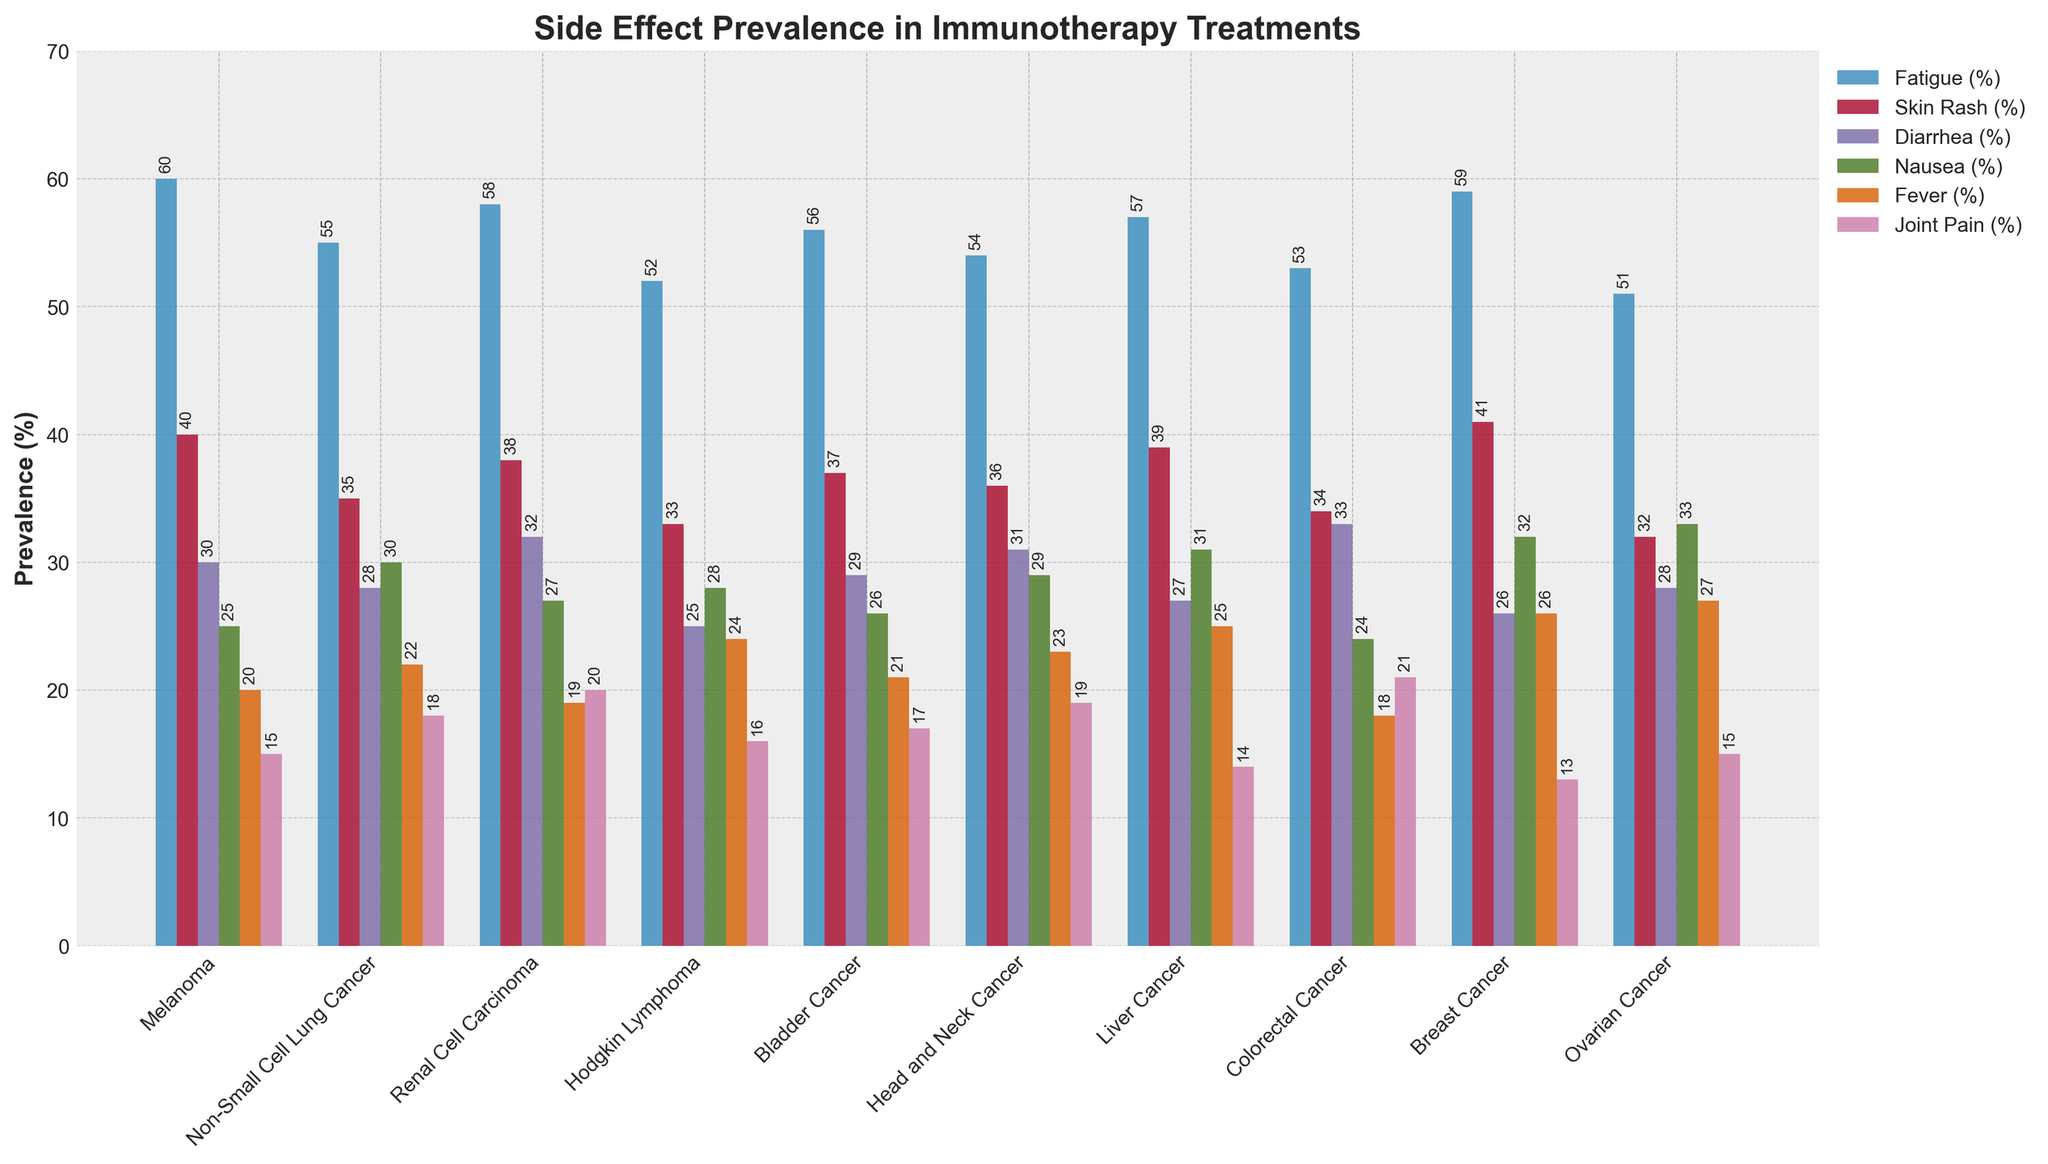Which cancer type has the highest prevalence of fatigue? The figure shows the prevalence of different side effects for various cancer types. By visually inspecting the bar representing fatigue across all cancer types, the highest one corresponds to Melanoma.
Answer: Melanoma What is the difference in the prevalence of fatigue between Melanoma and Non-Small Cell Lung Cancer? From the figure, the fatigue prevalence for Melanoma and Non-Small Cell Lung Cancer are 60% and 55% respectively. The difference is calculated as 60% - 55%.
Answer: 5% Which side effect has the largest difference in prevalence between Breast Cancer and Ovarian Cancer? By comparing the prevalence for each side effect between Breast Cancer and Ovarian Cancer, noting the differences: Fatigue (59% - 51%), Skin Rash (41% - 32%), Diarrhea (26% - 28%), Nausea (32% - 33%), Fever (26% - 27%), Joint Pain (13% - 15%). The largest difference is in Skin Rash (41% - 32%) = 9%.
Answer: Skin Rash Which two cancer types have an equal prevalence of nausea? By comparing the nausea prevalence across cancer types, both Liver Cancer and Breast Cancer show the same prevalence of 32%.
Answer: Liver Cancer and Breast Cancer What is the average prevalence of skin rash for all cancer types? Sum up the skin rash percentages for all cancer types (40% + 35% + 38% + 33% + 37% + 36% + 39% + 34% + 41% + 32%) = 365%. Then divide by the number of cancer types, which is 10. 365% / 10 = 36.5%.
Answer: 36.5% Which cancer type has the lowest prevalence of joint pain? The lowest prevalence of joint pain across all cancer types visually is Breast Cancer at 13%.
Answer: Breast Cancer What is the total prevalence of all side effects for Colorectal Cancer? Sum the prevalence percentages for fatigue, skin rash, diarrhea, nausea, fever, and joint pain for Colorectal Cancer (53% + 34% + 33% + 24% + 18% + 21%) = 183%.
Answer: 183% Which cancer type has a higher prevalence of diarrhea, Renal Cell Carcinoma or Head and Neck Cancer? By comparing the bars representing diarrhea for Renal Cell Carcinoma (32%) and Head and Neck Cancer (31%), Renal Cell Carcinoma has a slightly higher prevalence.
Answer: Renal Cell Carcinoma 